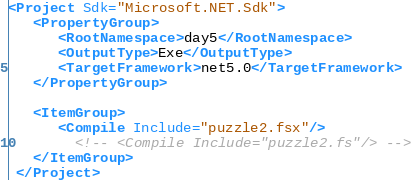<code> <loc_0><loc_0><loc_500><loc_500><_XML_><Project Sdk="Microsoft.NET.Sdk">
   <PropertyGroup>
      <RootNamespace>day5</RootNamespace>
      <OutputType>Exe</OutputType>
      <TargetFramework>net5.0</TargetFramework>
   </PropertyGroup>

   <ItemGroup>
      <Compile Include="puzzle2.fsx"/>
		<!-- <Compile Include="puzzle2.fs"/> -->
   </ItemGroup>
 </Project></code> 